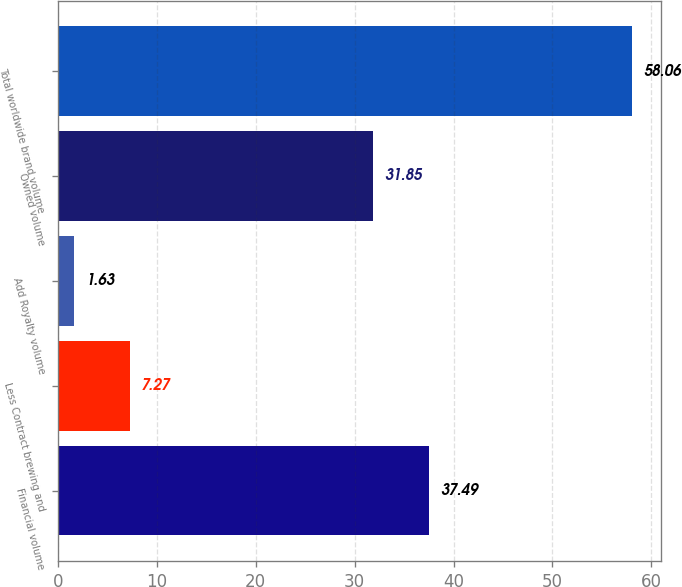<chart> <loc_0><loc_0><loc_500><loc_500><bar_chart><fcel>Financial volume<fcel>Less Contract brewing and<fcel>Add Royalty volume<fcel>Owned volume<fcel>Total worldwide brand volume<nl><fcel>37.49<fcel>7.27<fcel>1.63<fcel>31.85<fcel>58.06<nl></chart> 